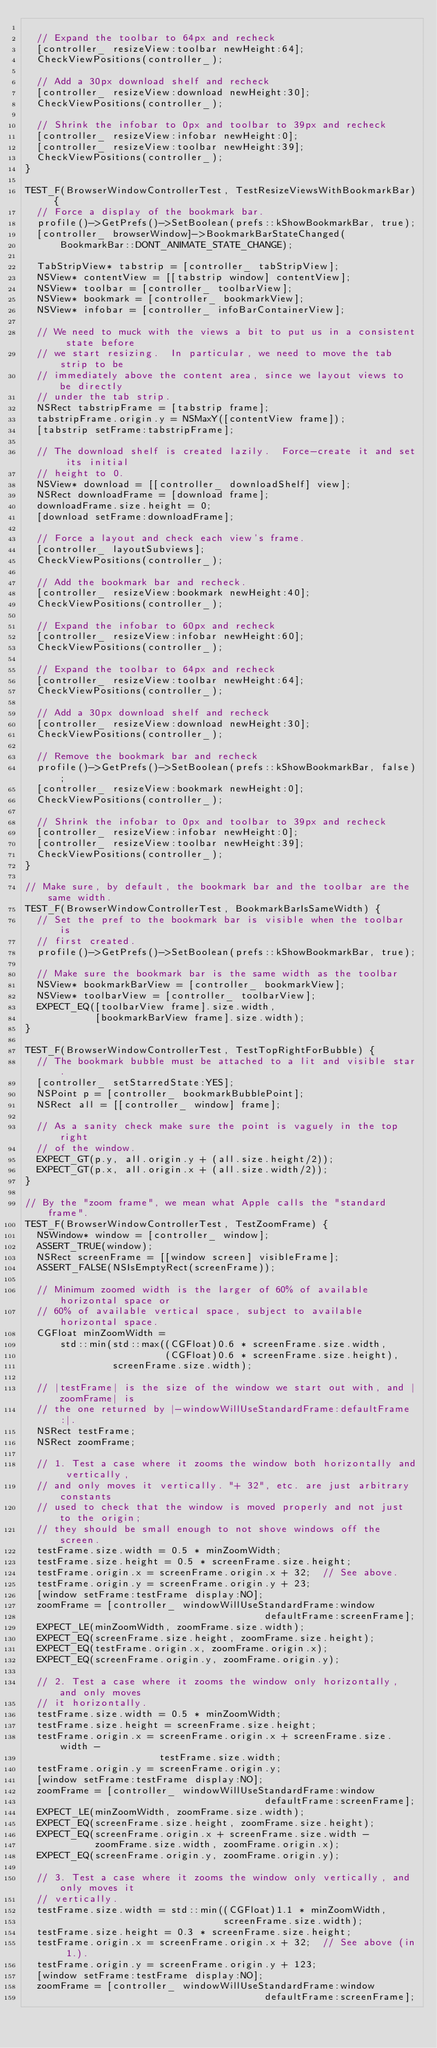Convert code to text. <code><loc_0><loc_0><loc_500><loc_500><_ObjectiveC_>
  // Expand the toolbar to 64px and recheck
  [controller_ resizeView:toolbar newHeight:64];
  CheckViewPositions(controller_);

  // Add a 30px download shelf and recheck
  [controller_ resizeView:download newHeight:30];
  CheckViewPositions(controller_);

  // Shrink the infobar to 0px and toolbar to 39px and recheck
  [controller_ resizeView:infobar newHeight:0];
  [controller_ resizeView:toolbar newHeight:39];
  CheckViewPositions(controller_);
}

TEST_F(BrowserWindowControllerTest, TestResizeViewsWithBookmarkBar) {
  // Force a display of the bookmark bar.
  profile()->GetPrefs()->SetBoolean(prefs::kShowBookmarkBar, true);
  [controller_ browserWindow]->BookmarkBarStateChanged(
      BookmarkBar::DONT_ANIMATE_STATE_CHANGE);

  TabStripView* tabstrip = [controller_ tabStripView];
  NSView* contentView = [[tabstrip window] contentView];
  NSView* toolbar = [controller_ toolbarView];
  NSView* bookmark = [controller_ bookmarkView];
  NSView* infobar = [controller_ infoBarContainerView];

  // We need to muck with the views a bit to put us in a consistent state before
  // we start resizing.  In particular, we need to move the tab strip to be
  // immediately above the content area, since we layout views to be directly
  // under the tab strip.
  NSRect tabstripFrame = [tabstrip frame];
  tabstripFrame.origin.y = NSMaxY([contentView frame]);
  [tabstrip setFrame:tabstripFrame];

  // The download shelf is created lazily.  Force-create it and set its initial
  // height to 0.
  NSView* download = [[controller_ downloadShelf] view];
  NSRect downloadFrame = [download frame];
  downloadFrame.size.height = 0;
  [download setFrame:downloadFrame];

  // Force a layout and check each view's frame.
  [controller_ layoutSubviews];
  CheckViewPositions(controller_);

  // Add the bookmark bar and recheck.
  [controller_ resizeView:bookmark newHeight:40];
  CheckViewPositions(controller_);

  // Expand the infobar to 60px and recheck
  [controller_ resizeView:infobar newHeight:60];
  CheckViewPositions(controller_);

  // Expand the toolbar to 64px and recheck
  [controller_ resizeView:toolbar newHeight:64];
  CheckViewPositions(controller_);

  // Add a 30px download shelf and recheck
  [controller_ resizeView:download newHeight:30];
  CheckViewPositions(controller_);

  // Remove the bookmark bar and recheck
  profile()->GetPrefs()->SetBoolean(prefs::kShowBookmarkBar, false);
  [controller_ resizeView:bookmark newHeight:0];
  CheckViewPositions(controller_);

  // Shrink the infobar to 0px and toolbar to 39px and recheck
  [controller_ resizeView:infobar newHeight:0];
  [controller_ resizeView:toolbar newHeight:39];
  CheckViewPositions(controller_);
}

// Make sure, by default, the bookmark bar and the toolbar are the same width.
TEST_F(BrowserWindowControllerTest, BookmarkBarIsSameWidth) {
  // Set the pref to the bookmark bar is visible when the toolbar is
  // first created.
  profile()->GetPrefs()->SetBoolean(prefs::kShowBookmarkBar, true);

  // Make sure the bookmark bar is the same width as the toolbar
  NSView* bookmarkBarView = [controller_ bookmarkView];
  NSView* toolbarView = [controller_ toolbarView];
  EXPECT_EQ([toolbarView frame].size.width,
            [bookmarkBarView frame].size.width);
}

TEST_F(BrowserWindowControllerTest, TestTopRightForBubble) {
  // The bookmark bubble must be attached to a lit and visible star.
  [controller_ setStarredState:YES];
  NSPoint p = [controller_ bookmarkBubblePoint];
  NSRect all = [[controller_ window] frame];

  // As a sanity check make sure the point is vaguely in the top right
  // of the window.
  EXPECT_GT(p.y, all.origin.y + (all.size.height/2));
  EXPECT_GT(p.x, all.origin.x + (all.size.width/2));
}

// By the "zoom frame", we mean what Apple calls the "standard frame".
TEST_F(BrowserWindowControllerTest, TestZoomFrame) {
  NSWindow* window = [controller_ window];
  ASSERT_TRUE(window);
  NSRect screenFrame = [[window screen] visibleFrame];
  ASSERT_FALSE(NSIsEmptyRect(screenFrame));

  // Minimum zoomed width is the larger of 60% of available horizontal space or
  // 60% of available vertical space, subject to available horizontal space.
  CGFloat minZoomWidth =
      std::min(std::max((CGFloat)0.6 * screenFrame.size.width,
                        (CGFloat)0.6 * screenFrame.size.height),
               screenFrame.size.width);

  // |testFrame| is the size of the window we start out with, and |zoomFrame| is
  // the one returned by |-windowWillUseStandardFrame:defaultFrame:|.
  NSRect testFrame;
  NSRect zoomFrame;

  // 1. Test a case where it zooms the window both horizontally and vertically,
  // and only moves it vertically. "+ 32", etc. are just arbitrary constants
  // used to check that the window is moved properly and not just to the origin;
  // they should be small enough to not shove windows off the screen.
  testFrame.size.width = 0.5 * minZoomWidth;
  testFrame.size.height = 0.5 * screenFrame.size.height;
  testFrame.origin.x = screenFrame.origin.x + 32;  // See above.
  testFrame.origin.y = screenFrame.origin.y + 23;
  [window setFrame:testFrame display:NO];
  zoomFrame = [controller_ windowWillUseStandardFrame:window
                                         defaultFrame:screenFrame];
  EXPECT_LE(minZoomWidth, zoomFrame.size.width);
  EXPECT_EQ(screenFrame.size.height, zoomFrame.size.height);
  EXPECT_EQ(testFrame.origin.x, zoomFrame.origin.x);
  EXPECT_EQ(screenFrame.origin.y, zoomFrame.origin.y);

  // 2. Test a case where it zooms the window only horizontally, and only moves
  // it horizontally.
  testFrame.size.width = 0.5 * minZoomWidth;
  testFrame.size.height = screenFrame.size.height;
  testFrame.origin.x = screenFrame.origin.x + screenFrame.size.width -
                       testFrame.size.width;
  testFrame.origin.y = screenFrame.origin.y;
  [window setFrame:testFrame display:NO];
  zoomFrame = [controller_ windowWillUseStandardFrame:window
                                         defaultFrame:screenFrame];
  EXPECT_LE(minZoomWidth, zoomFrame.size.width);
  EXPECT_EQ(screenFrame.size.height, zoomFrame.size.height);
  EXPECT_EQ(screenFrame.origin.x + screenFrame.size.width -
            zoomFrame.size.width, zoomFrame.origin.x);
  EXPECT_EQ(screenFrame.origin.y, zoomFrame.origin.y);

  // 3. Test a case where it zooms the window only vertically, and only moves it
  // vertically.
  testFrame.size.width = std::min((CGFloat)1.1 * minZoomWidth,
                                  screenFrame.size.width);
  testFrame.size.height = 0.3 * screenFrame.size.height;
  testFrame.origin.x = screenFrame.origin.x + 32;  // See above (in 1.).
  testFrame.origin.y = screenFrame.origin.y + 123;
  [window setFrame:testFrame display:NO];
  zoomFrame = [controller_ windowWillUseStandardFrame:window
                                         defaultFrame:screenFrame];</code> 